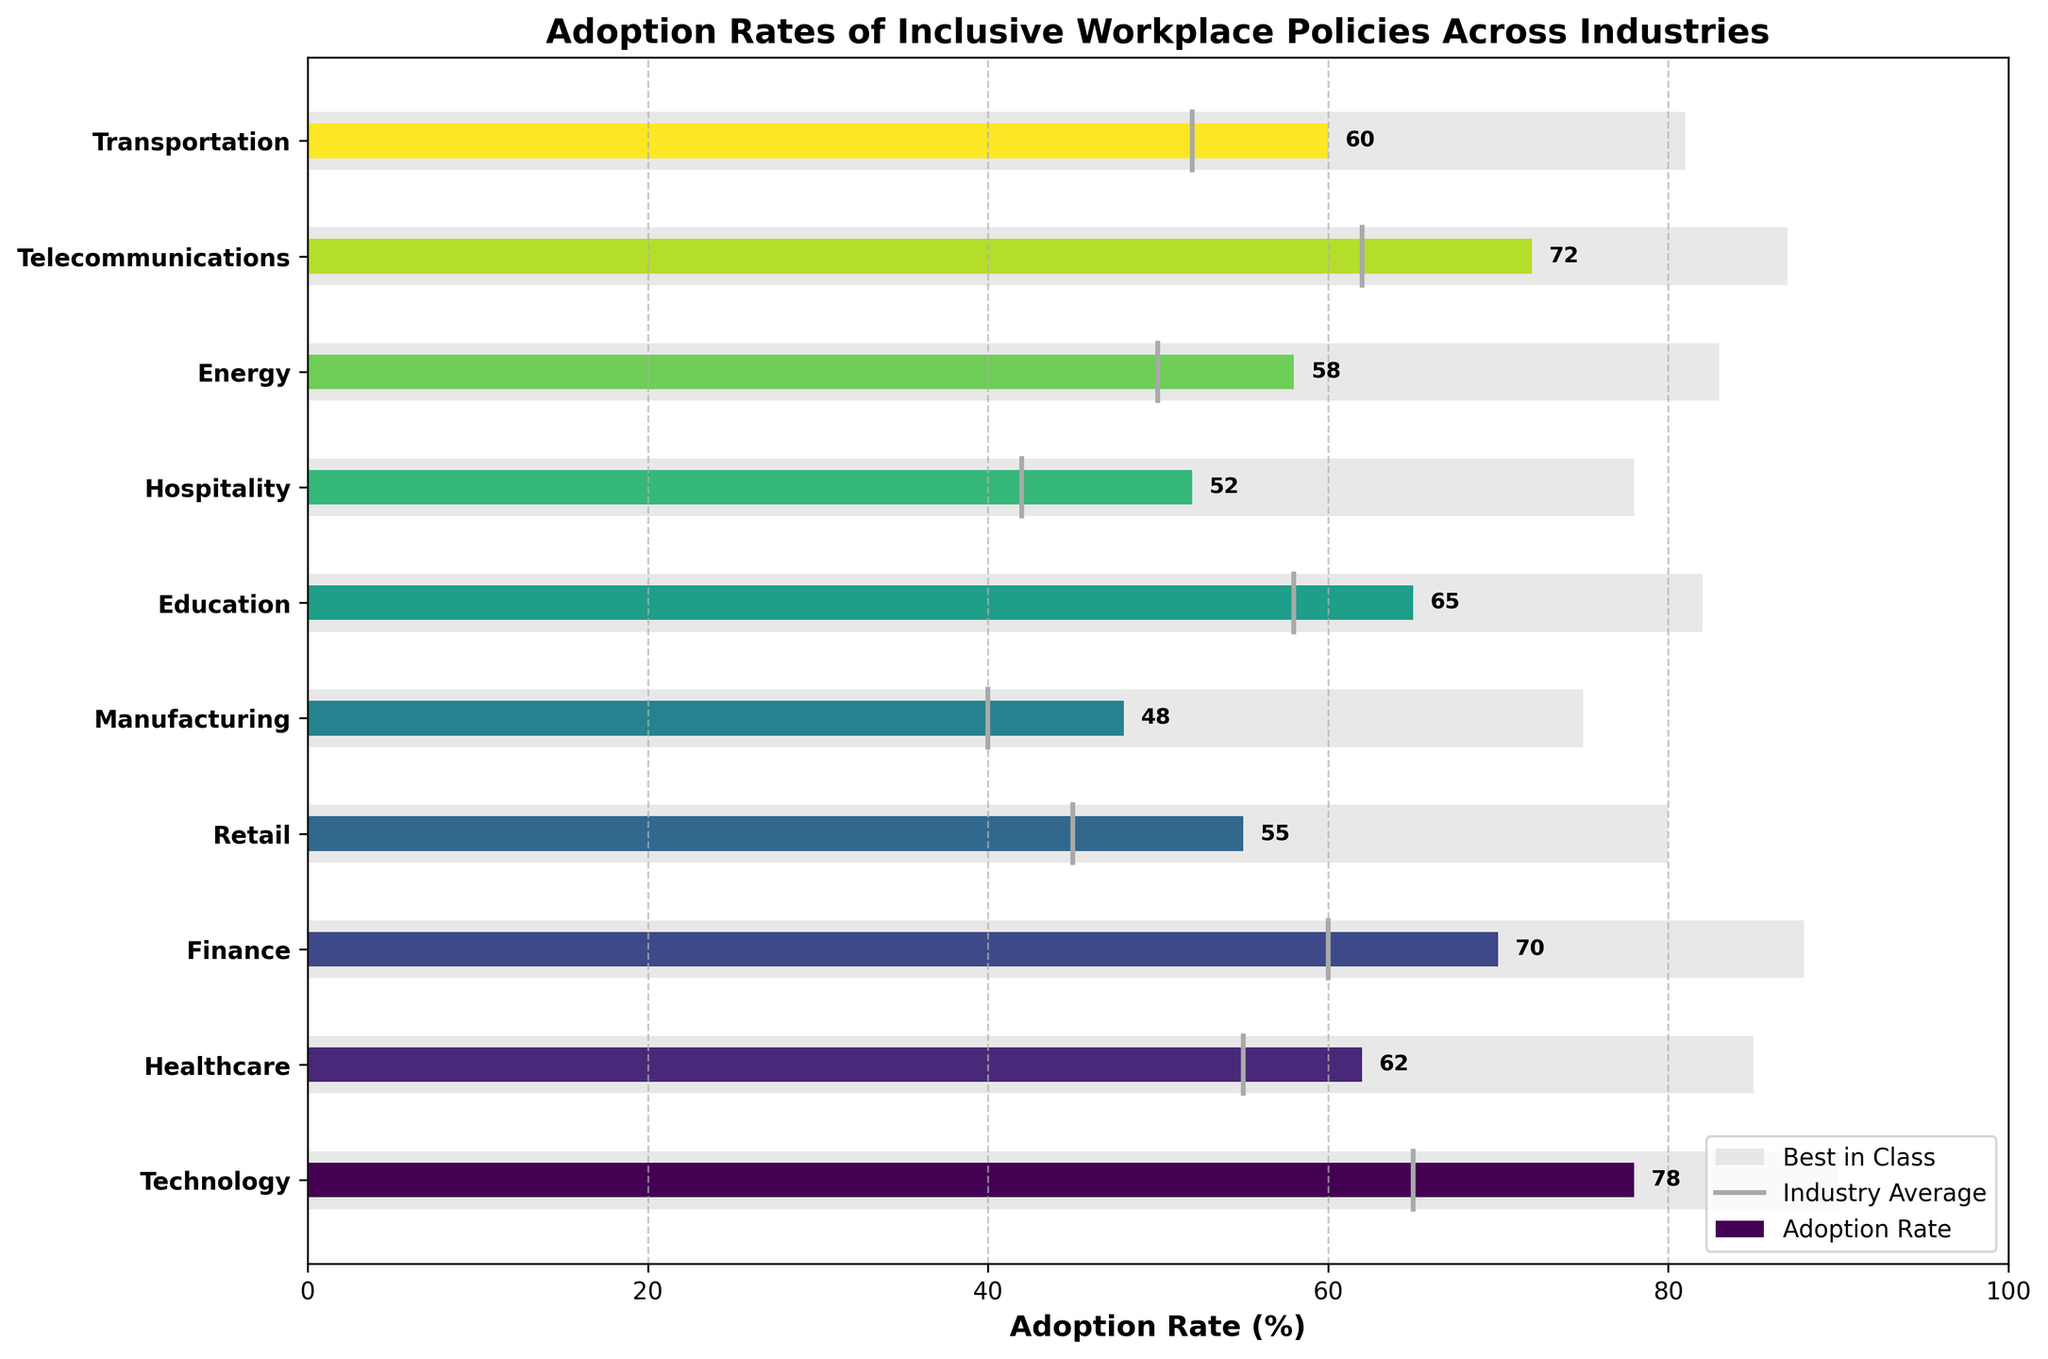What is the adoption rate for the Technology industry? The Technology industry is the first bar from the top. Reading the value from the plot shows an adoption rate of 78.
Answer: 78 How does the Healthcare industry's adoption rate compare to its industry average? Looking at the Healthcare industry bar, its adoption rate is 62. The industry average line for Healthcare is at 55. Comparing these values shows that Healthcare's adoption rate is 7 points higher than its industry average.
Answer: 7 points higher Which industry has the highest adoption rate? The bar with the longest length corresponds to the highest adoption rate. The Technology industry has the longest bar, indicating the highest adoption rate.
Answer: Technology What is the difference between the best in class and adoption rate for the Manufacturing industry? The best in class value for Manufacturing is 75. The adoption rate for Manufacturing is 48. Subtracting 48 from 75 gives 27.
Answer: 27 How many industries have adoption rates above 60? By checking each bar, the industries with adoption rates above 60 are Technology (78), Healthcare (62), Finance (70), Education (65), Telecommunications (72), and Transportation (60). Counting these gives a total of 6 industries.
Answer: 6 Which industry is closest to reaching its best in class value? Calculating the difference between the best in class and the adoption rate for each industry, the smallest difference indicates the closest distance. Telecommunications has a best in class of 87 and an adoption rate of 72, so the difference is 15, which is the smallest.
Answer: Telecommunications (15 points) What is the average adoption rate across all industries? Adding all adoption rates: 78 + 62 + 70 + 55 + 48 + 65 + 52 + 58 + 72 + 60 = 620. Dividing by the number of industries, 620 / 10 = 62.
Answer: 62 How does the Energy industry's adoption rate compare to the Retail industry's? The adoption rate for Energy is 58, and for Retail, it is 55. Comparing these shows that Energy's adoption rate is 3 points higher than Retail's.
Answer: 3 points higher In what range do most industry averages fall? Observing the lines indicating industry averages, most fall between 40 to 60%.
Answer: 40-60% What is the most common color used in the adoption rate bars? The colors in the adoption rate bars vary in shades of blue to green (viridis color map). The most common color spectrum used appears to be a gradient from blue to green.
Answer: Blue to green gradient 